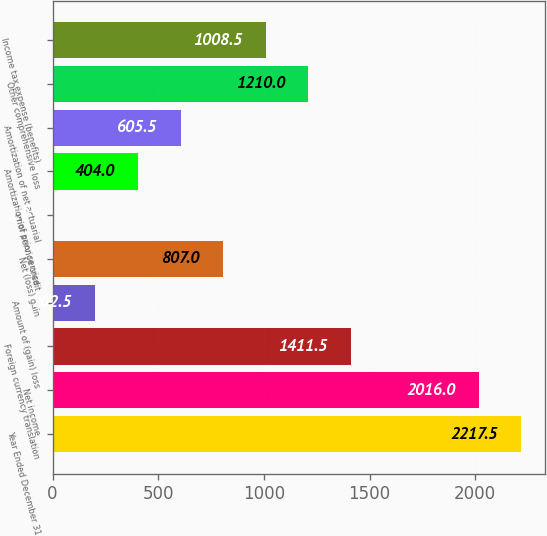Convert chart to OTSL. <chart><loc_0><loc_0><loc_500><loc_500><bar_chart><fcel>Year Ended December 31<fcel>Net income<fcel>Foreign currency translation<fcel>Amount of (gain) loss<fcel>Net (loss) gain<fcel>Prior service credit<fcel>Amortization of prior service<fcel>Amortization of net actuarial<fcel>Other comprehensive loss<fcel>Income tax expense (benefits)<nl><fcel>2217.5<fcel>2016<fcel>1411.5<fcel>202.5<fcel>807<fcel>1<fcel>404<fcel>605.5<fcel>1210<fcel>1008.5<nl></chart> 